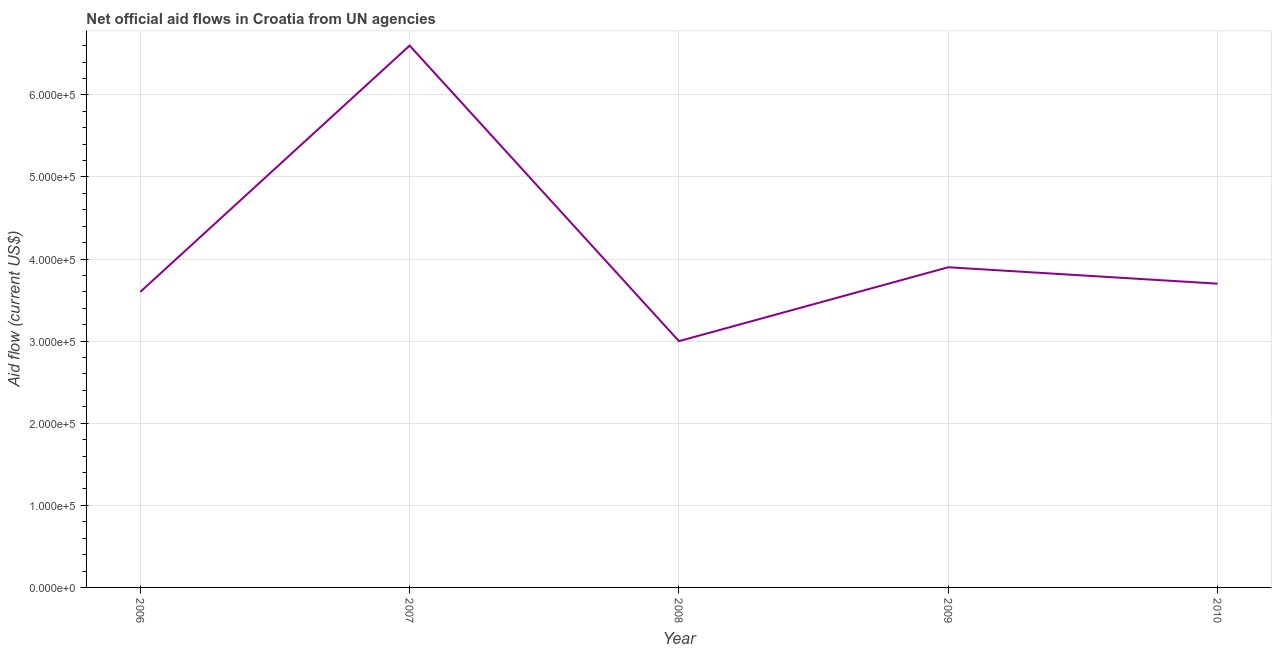What is the net official flows from un agencies in 2010?
Keep it short and to the point. 3.70e+05. Across all years, what is the maximum net official flows from un agencies?
Give a very brief answer. 6.60e+05. Across all years, what is the minimum net official flows from un agencies?
Offer a terse response. 3.00e+05. What is the sum of the net official flows from un agencies?
Offer a very short reply. 2.08e+06. What is the difference between the net official flows from un agencies in 2009 and 2010?
Make the answer very short. 2.00e+04. What is the average net official flows from un agencies per year?
Ensure brevity in your answer.  4.16e+05. What is the median net official flows from un agencies?
Your answer should be compact. 3.70e+05. In how many years, is the net official flows from un agencies greater than 460000 US$?
Ensure brevity in your answer.  1. What is the ratio of the net official flows from un agencies in 2006 to that in 2008?
Keep it short and to the point. 1.2. Is the difference between the net official flows from un agencies in 2008 and 2009 greater than the difference between any two years?
Your answer should be compact. No. What is the difference between the highest and the lowest net official flows from un agencies?
Your answer should be compact. 3.60e+05. In how many years, is the net official flows from un agencies greater than the average net official flows from un agencies taken over all years?
Make the answer very short. 1. Does the net official flows from un agencies monotonically increase over the years?
Provide a short and direct response. No. How many years are there in the graph?
Ensure brevity in your answer.  5. What is the difference between two consecutive major ticks on the Y-axis?
Provide a succinct answer. 1.00e+05. Are the values on the major ticks of Y-axis written in scientific E-notation?
Your response must be concise. Yes. What is the title of the graph?
Your answer should be very brief. Net official aid flows in Croatia from UN agencies. What is the label or title of the X-axis?
Make the answer very short. Year. What is the label or title of the Y-axis?
Offer a terse response. Aid flow (current US$). What is the Aid flow (current US$) in 2008?
Your response must be concise. 3.00e+05. What is the Aid flow (current US$) of 2010?
Make the answer very short. 3.70e+05. What is the difference between the Aid flow (current US$) in 2006 and 2007?
Provide a short and direct response. -3.00e+05. What is the difference between the Aid flow (current US$) in 2006 and 2009?
Your answer should be very brief. -3.00e+04. What is the difference between the Aid flow (current US$) in 2007 and 2008?
Make the answer very short. 3.60e+05. What is the difference between the Aid flow (current US$) in 2007 and 2009?
Offer a terse response. 2.70e+05. What is the difference between the Aid flow (current US$) in 2007 and 2010?
Ensure brevity in your answer.  2.90e+05. What is the difference between the Aid flow (current US$) in 2008 and 2010?
Give a very brief answer. -7.00e+04. What is the ratio of the Aid flow (current US$) in 2006 to that in 2007?
Offer a terse response. 0.55. What is the ratio of the Aid flow (current US$) in 2006 to that in 2009?
Keep it short and to the point. 0.92. What is the ratio of the Aid flow (current US$) in 2007 to that in 2008?
Your answer should be compact. 2.2. What is the ratio of the Aid flow (current US$) in 2007 to that in 2009?
Provide a succinct answer. 1.69. What is the ratio of the Aid flow (current US$) in 2007 to that in 2010?
Provide a short and direct response. 1.78. What is the ratio of the Aid flow (current US$) in 2008 to that in 2009?
Provide a short and direct response. 0.77. What is the ratio of the Aid flow (current US$) in 2008 to that in 2010?
Your answer should be compact. 0.81. What is the ratio of the Aid flow (current US$) in 2009 to that in 2010?
Keep it short and to the point. 1.05. 